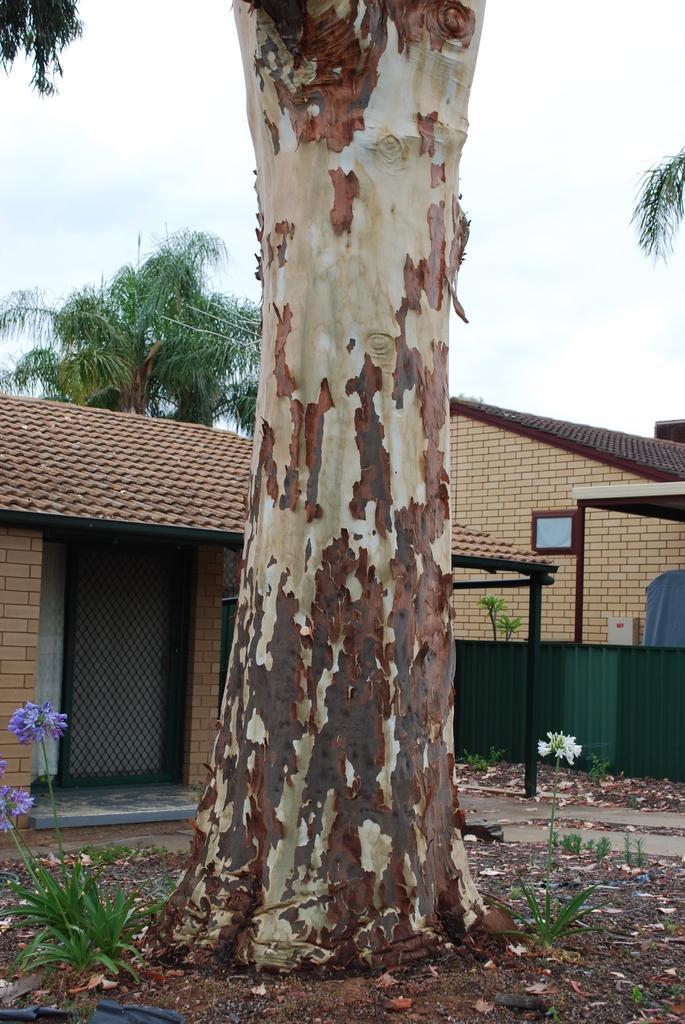Can you describe this image briefly? In this image we can see sky, trees, buildings, poles, ground, shredded leaves and ground. 